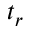Convert formula to latex. <formula><loc_0><loc_0><loc_500><loc_500>t _ { r }</formula> 